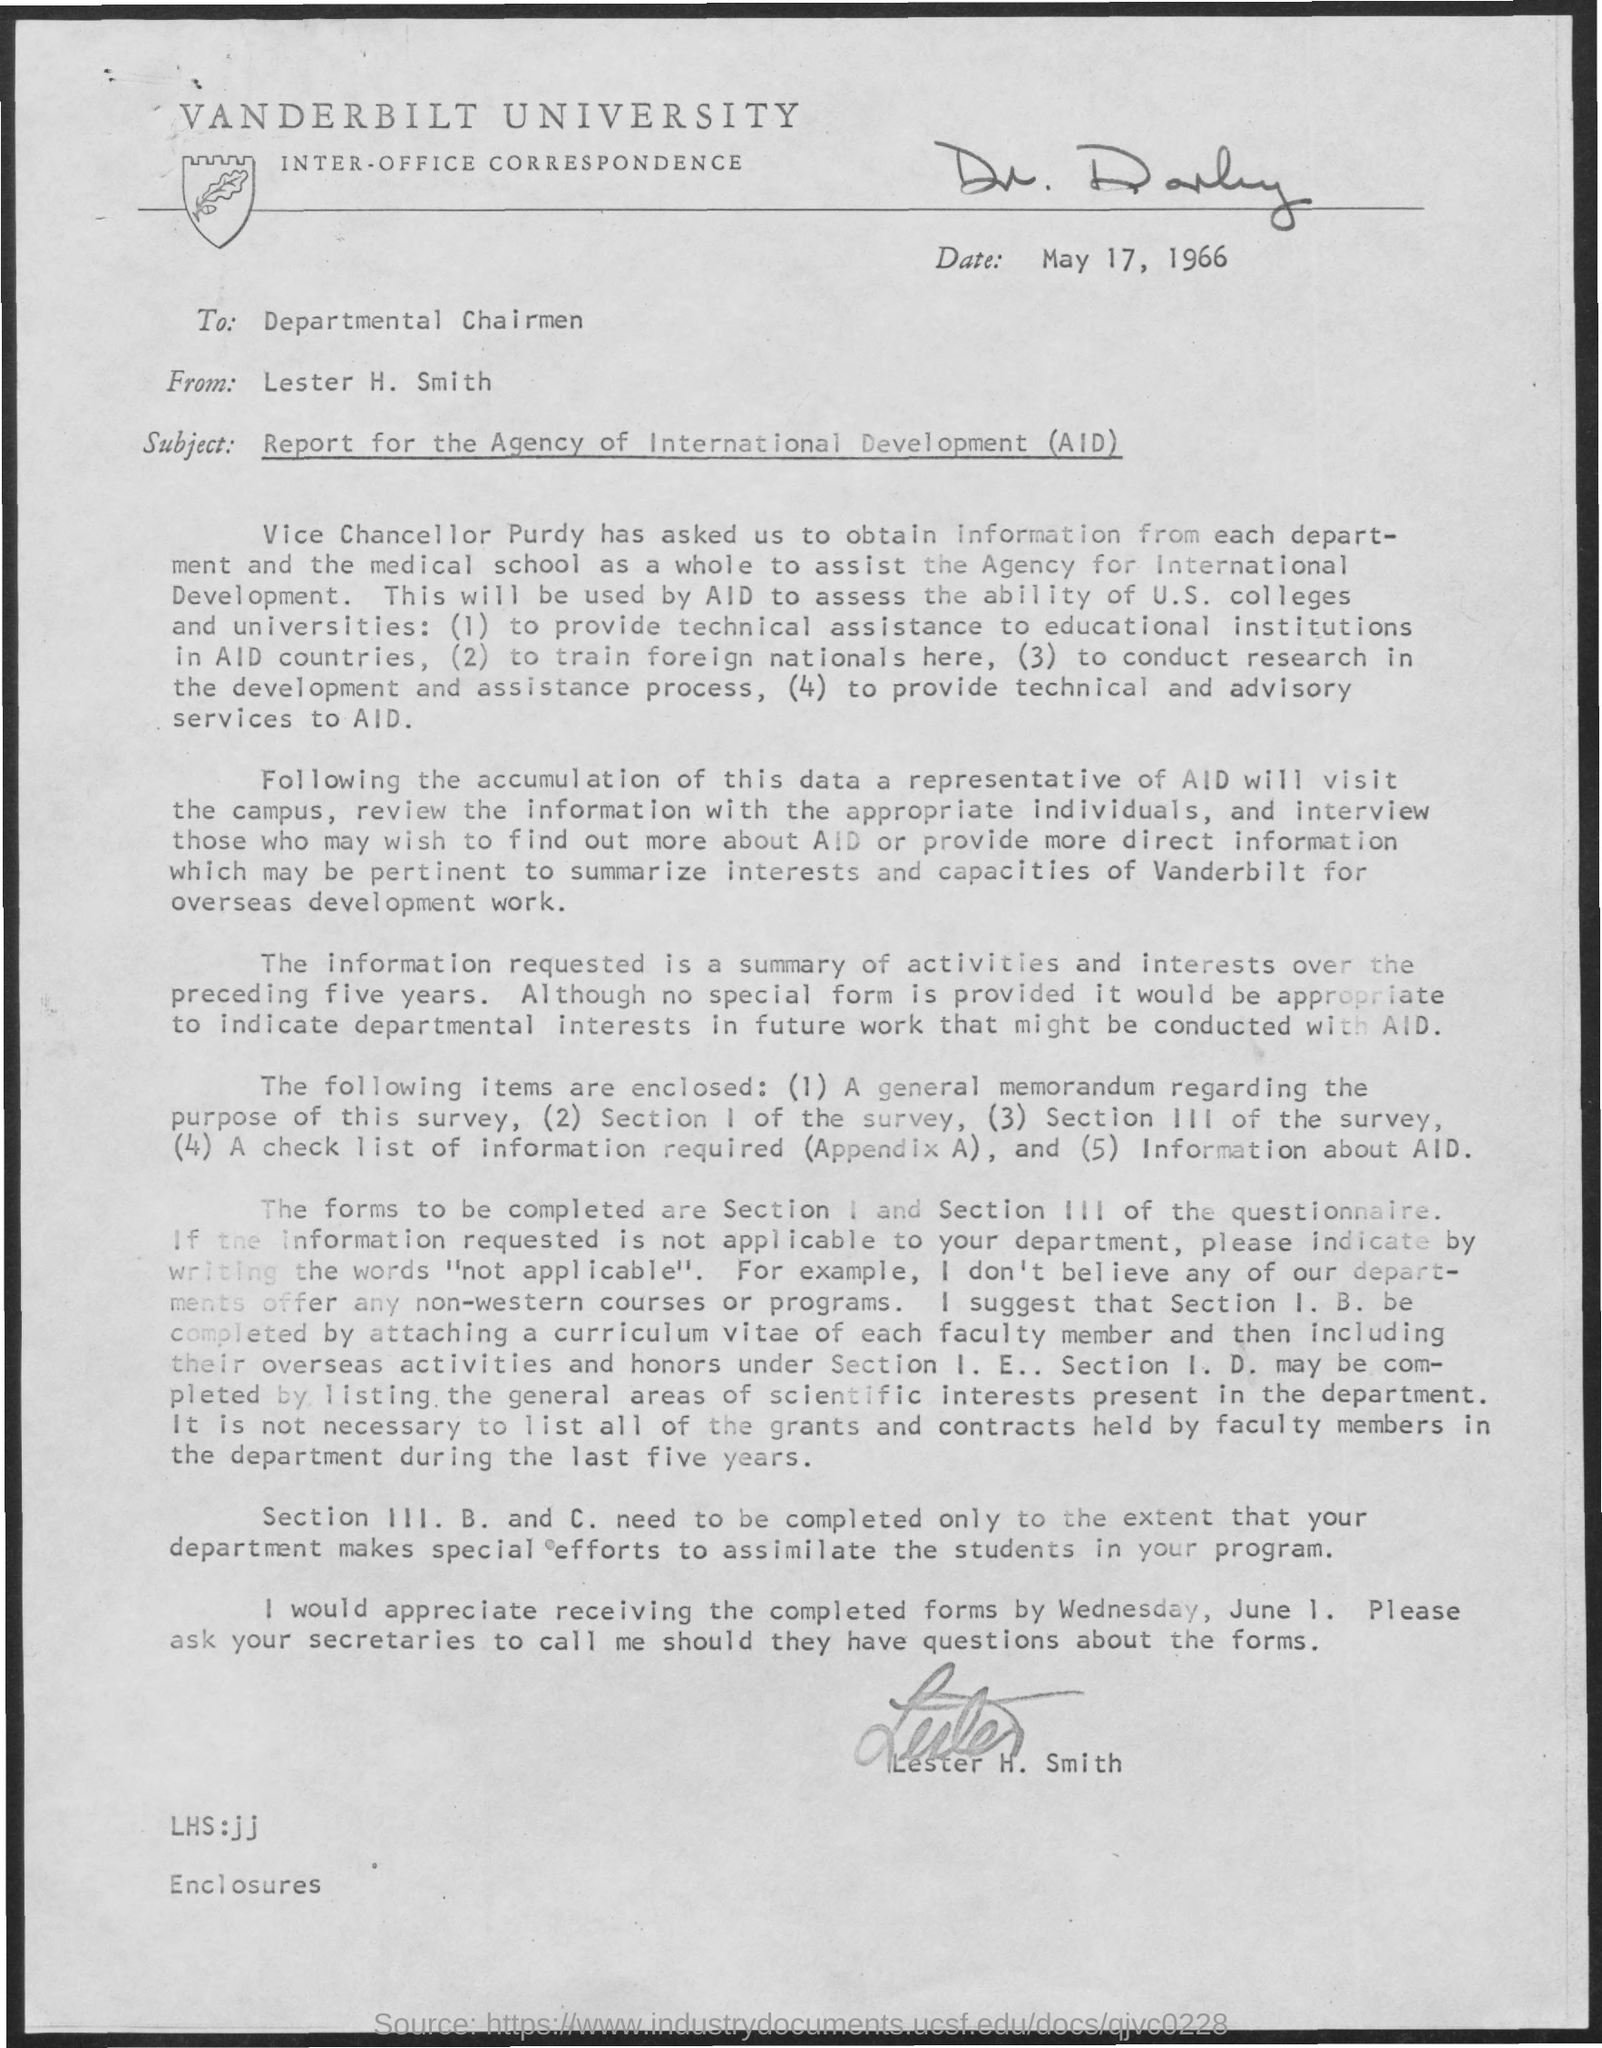What is the name of the university ?
Provide a succinct answer. Vanderbilt university. What is the date mentioned ?
Keep it short and to the point. MAY 17, 1966. To whom this letter is written
Keep it short and to the point. DEPARTMENTAL CHAIRMAN. From whom this letter is written
Provide a short and direct response. LESTER H. SMITH. I would appreciate receiving the completed forms by when ?
Provide a short and direct response. Wednesday , june 1. 